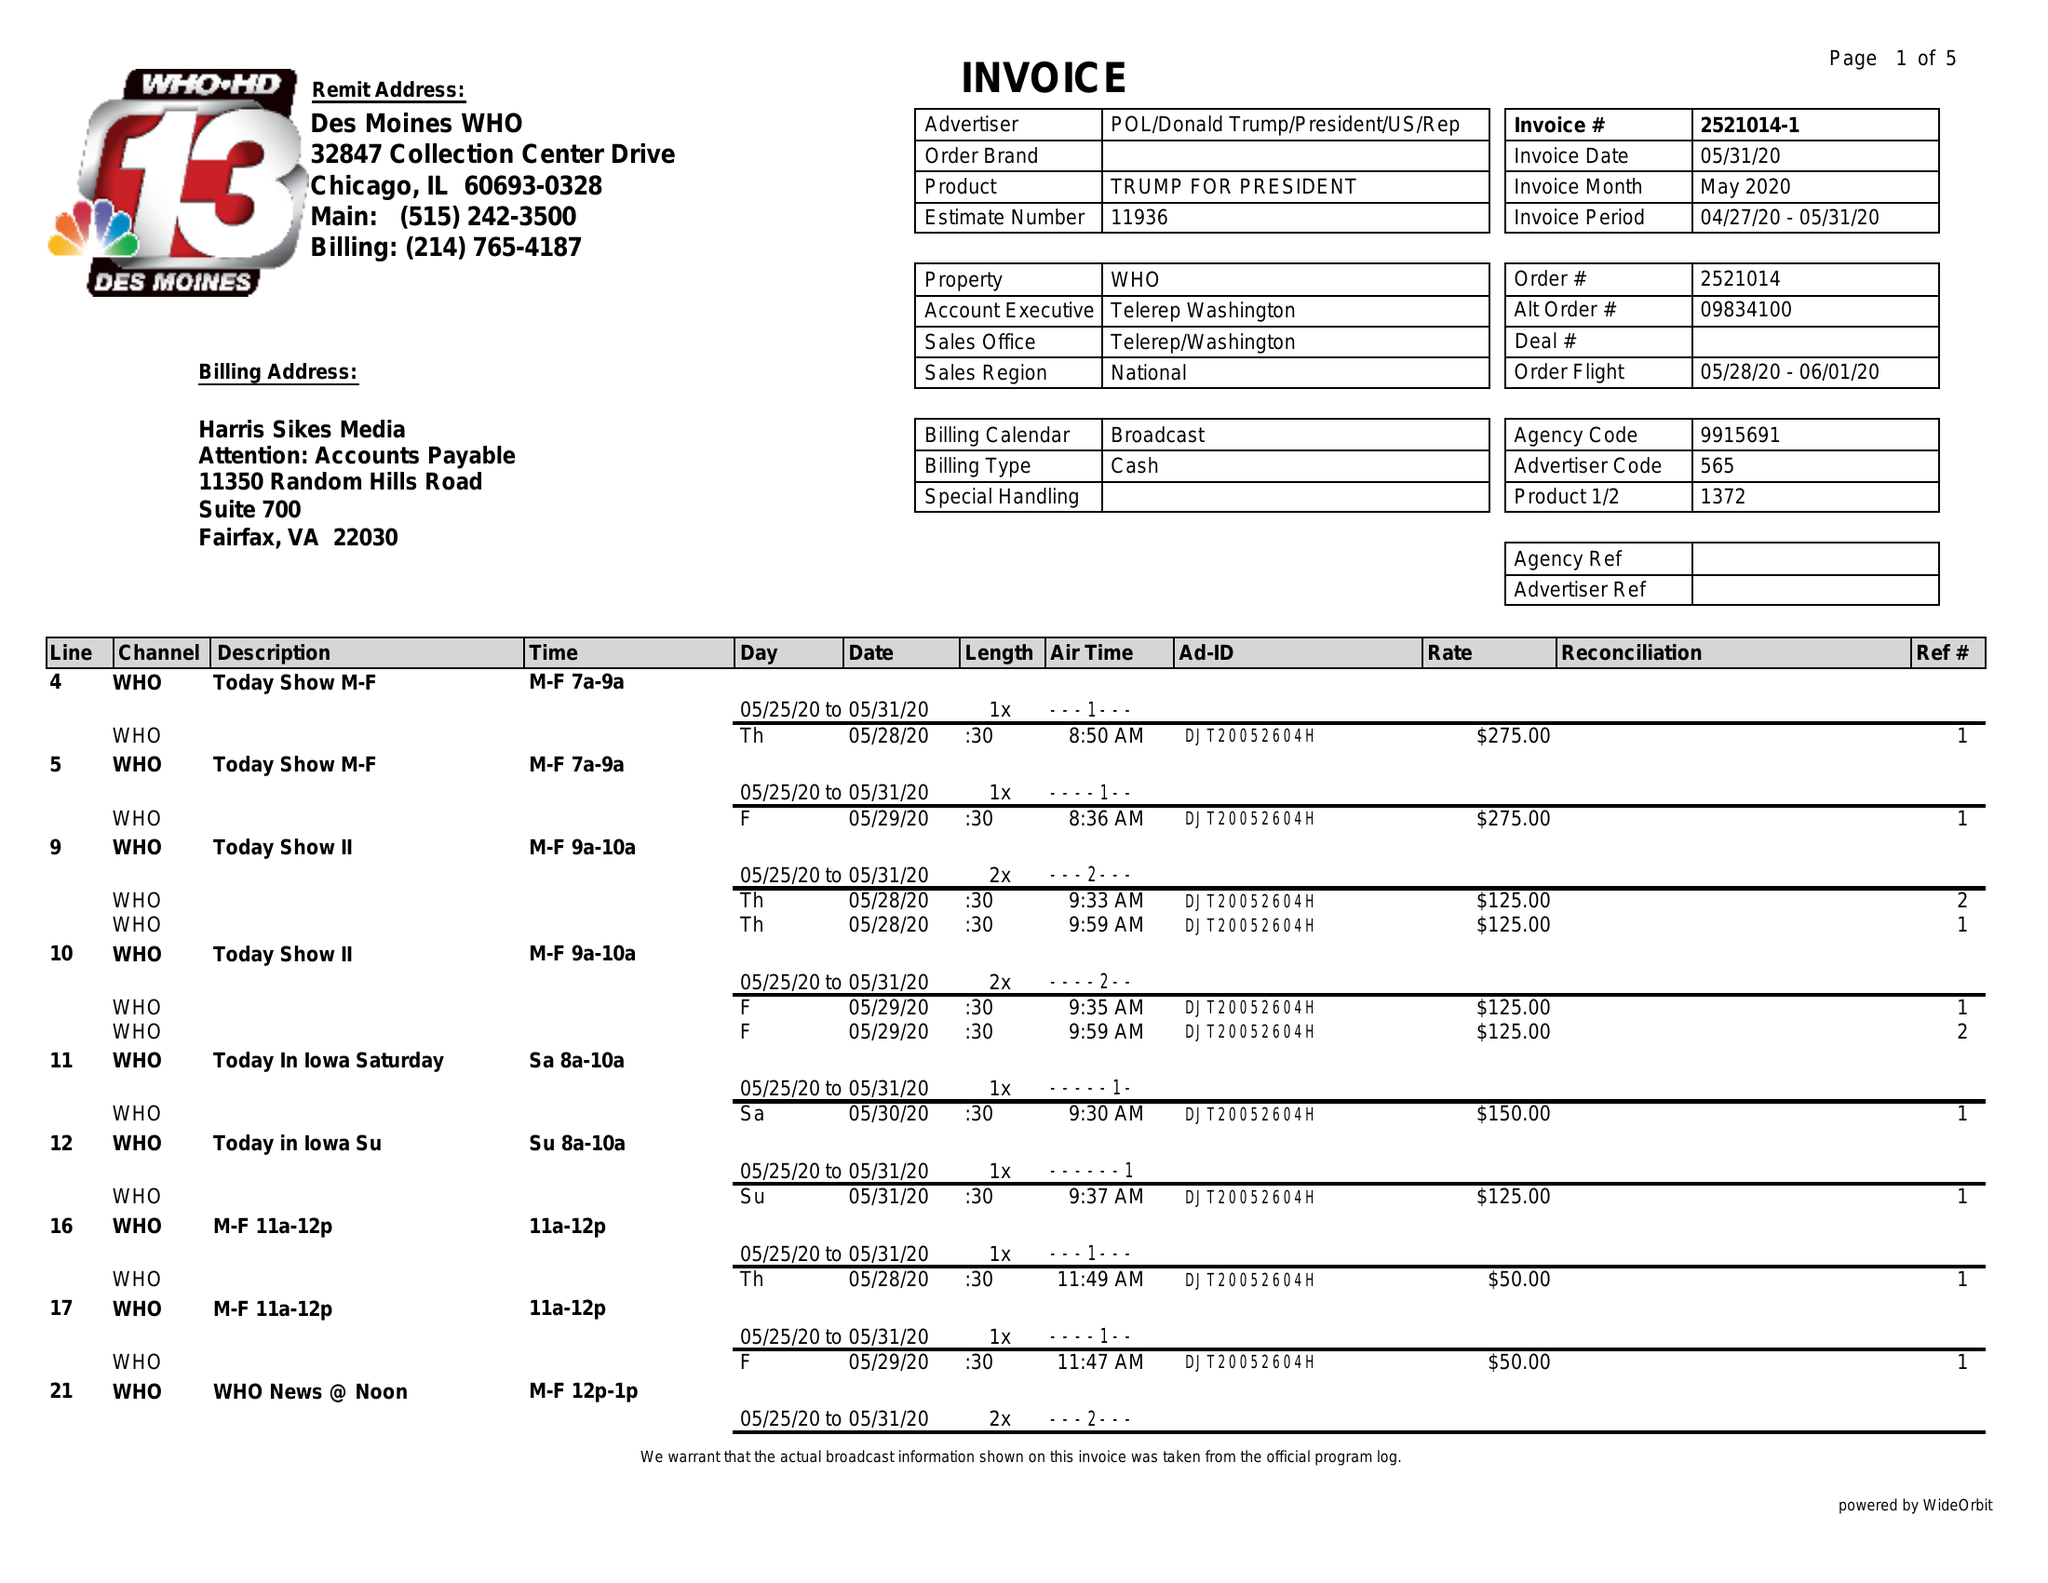What is the value for the advertiser?
Answer the question using a single word or phrase. POL/DONALDTRUMP/PRESIDENT/US/REP 